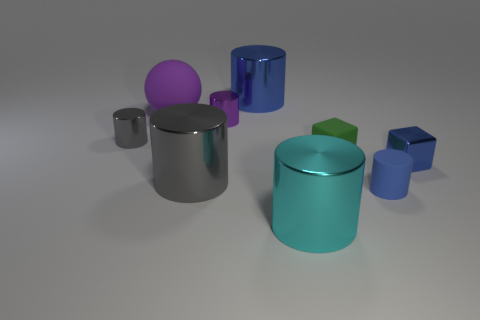There is a purple shiny thing; does it have the same size as the cylinder that is behind the large matte thing?
Give a very brief answer. No. Is there a brown cube that has the same size as the blue metal cube?
Your response must be concise. No. What number of things are either large matte balls or gray shiny cubes?
Give a very brief answer. 1. There is a blue metal cylinder that is on the right side of the rubber ball; does it have the same size as the cylinder that is in front of the tiny blue cylinder?
Offer a terse response. Yes. Are there any large blue objects of the same shape as the tiny blue rubber thing?
Ensure brevity in your answer.  Yes. Are there fewer cylinders behind the small blue metallic block than large gray metallic things?
Give a very brief answer. No. Is the big gray metal object the same shape as the tiny blue matte thing?
Keep it short and to the point. Yes. What is the size of the gray object on the left side of the large gray thing?
Offer a very short reply. Small. What size is the blue cylinder that is made of the same material as the tiny green object?
Give a very brief answer. Small. Are there fewer balls than gray metallic spheres?
Offer a terse response. No. 